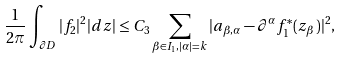Convert formula to latex. <formula><loc_0><loc_0><loc_500><loc_500>\frac { 1 } { 2 \pi } \int _ { \partial D } | f _ { 2 } | ^ { 2 } | d z | \leq C _ { 3 } \sum _ { \beta \in I _ { 1 } , | \alpha | = k } | a _ { \beta , \alpha } - \partial ^ { \alpha } f _ { 1 } ^ { * } ( z _ { \beta } ) | ^ { 2 } ,</formula> 